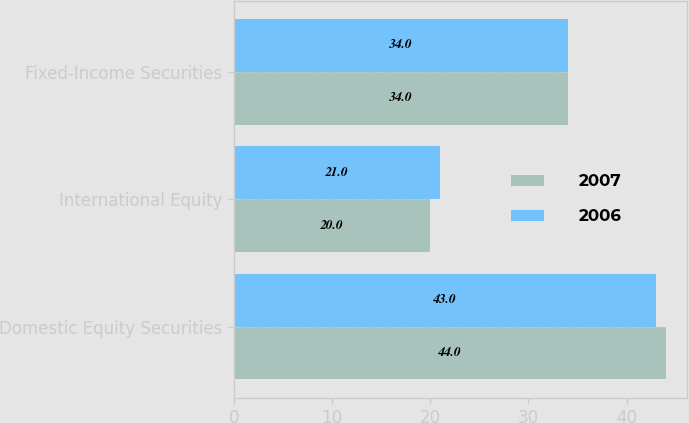<chart> <loc_0><loc_0><loc_500><loc_500><stacked_bar_chart><ecel><fcel>Domestic Equity Securities<fcel>International Equity<fcel>Fixed-Income Securities<nl><fcel>2007<fcel>44<fcel>20<fcel>34<nl><fcel>2006<fcel>43<fcel>21<fcel>34<nl></chart> 